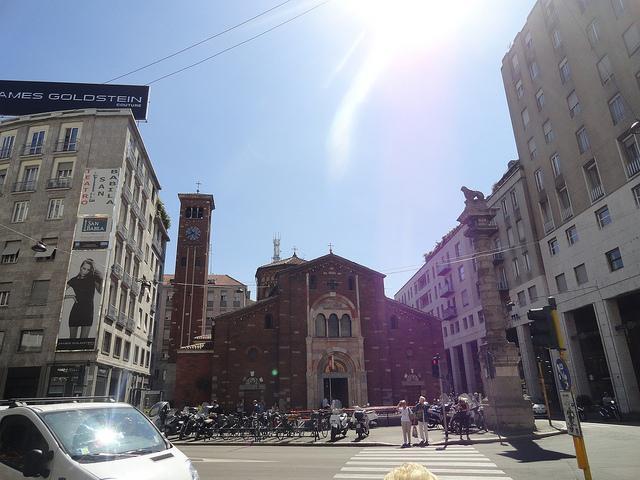How many cows are lying down?
Give a very brief answer. 0. 